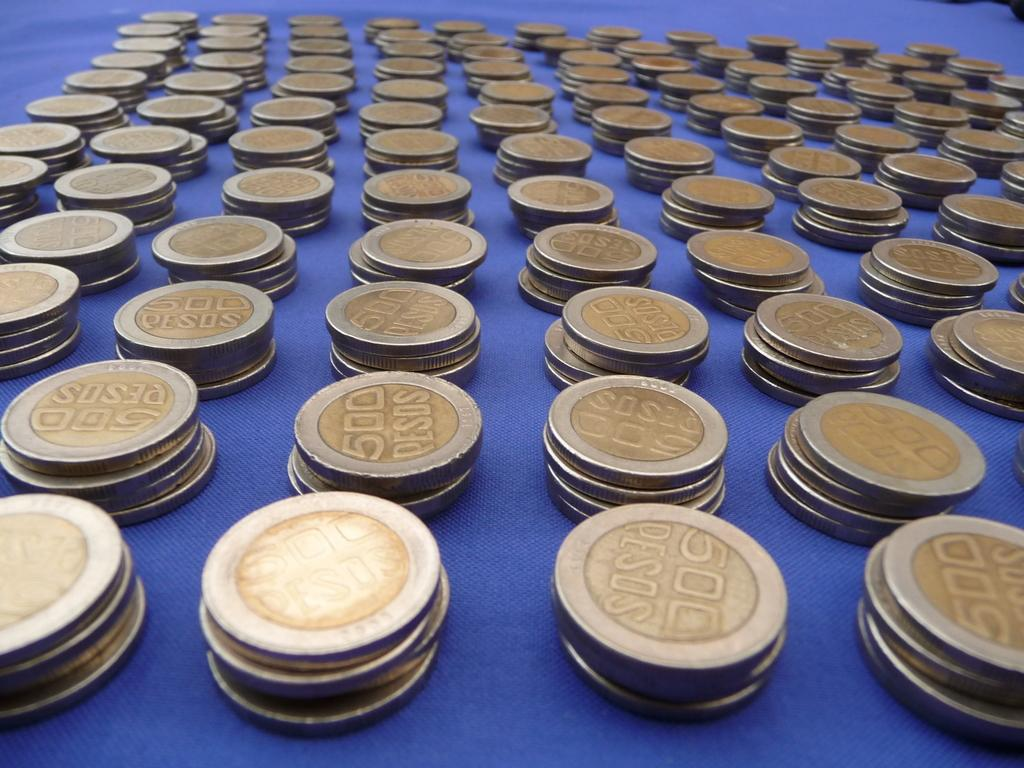<image>
Create a compact narrative representing the image presented. Several stacks of 500 peso coins are on top of a blue surface. 